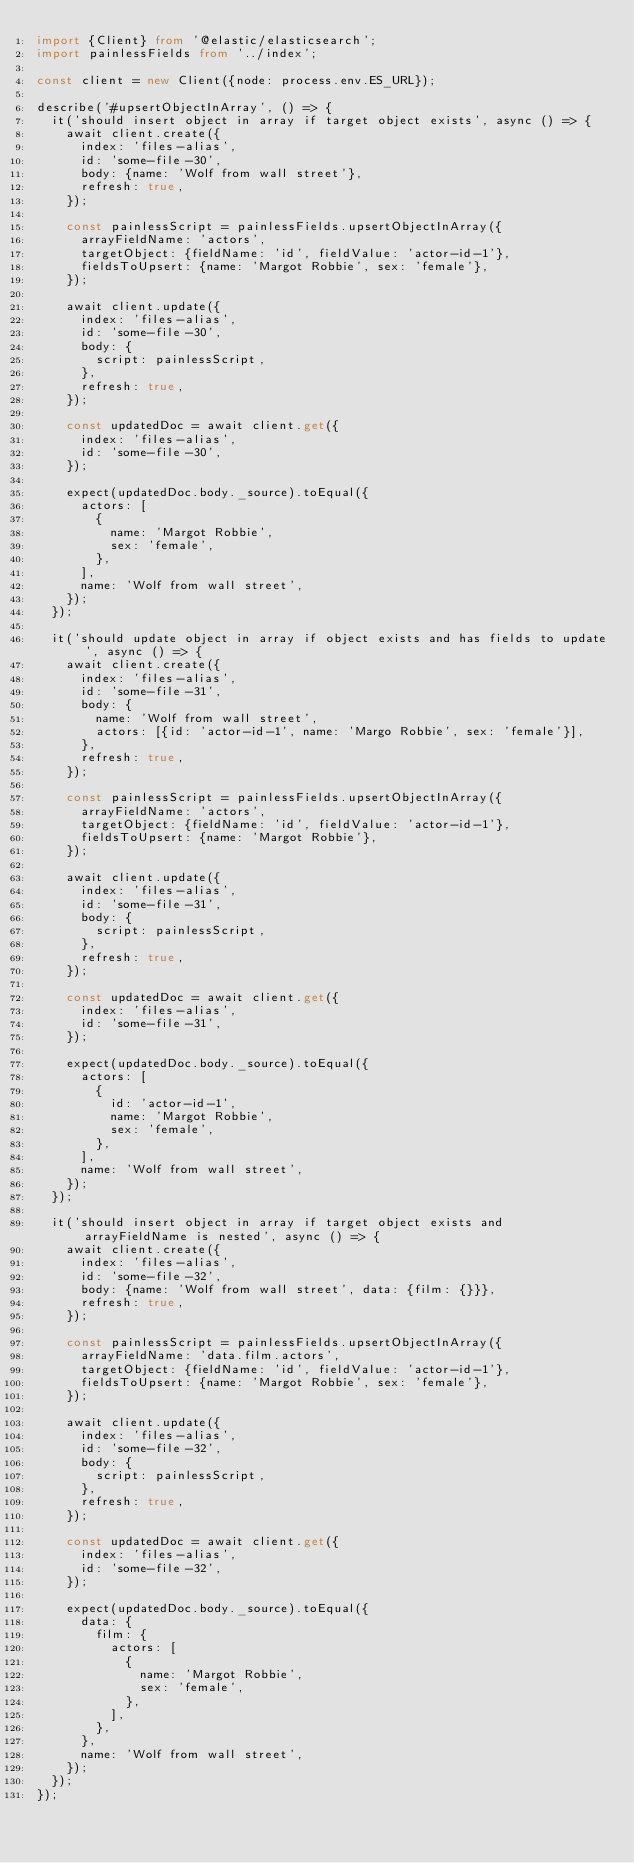<code> <loc_0><loc_0><loc_500><loc_500><_TypeScript_>import {Client} from '@elastic/elasticsearch';
import painlessFields from '../index';

const client = new Client({node: process.env.ES_URL});

describe('#upsertObjectInArray', () => {
  it('should insert object in array if target object exists', async () => {
    await client.create({
      index: 'files-alias',
      id: 'some-file-30',
      body: {name: 'Wolf from wall street'},
      refresh: true,
    });

    const painlessScript = painlessFields.upsertObjectInArray({
      arrayFieldName: 'actors',
      targetObject: {fieldName: 'id', fieldValue: 'actor-id-1'},
      fieldsToUpsert: {name: 'Margot Robbie', sex: 'female'},
    });

    await client.update({
      index: 'files-alias',
      id: 'some-file-30',
      body: {
        script: painlessScript,
      },
      refresh: true,
    });

    const updatedDoc = await client.get({
      index: 'files-alias',
      id: 'some-file-30',
    });

    expect(updatedDoc.body._source).toEqual({
      actors: [
        {
          name: 'Margot Robbie',
          sex: 'female',
        },
      ],
      name: 'Wolf from wall street',
    });
  });

  it('should update object in array if object exists and has fields to update', async () => {
    await client.create({
      index: 'files-alias',
      id: 'some-file-31',
      body: {
        name: 'Wolf from wall street',
        actors: [{id: 'actor-id-1', name: 'Margo Robbie', sex: 'female'}],
      },
      refresh: true,
    });

    const painlessScript = painlessFields.upsertObjectInArray({
      arrayFieldName: 'actors',
      targetObject: {fieldName: 'id', fieldValue: 'actor-id-1'},
      fieldsToUpsert: {name: 'Margot Robbie'},
    });

    await client.update({
      index: 'files-alias',
      id: 'some-file-31',
      body: {
        script: painlessScript,
      },
      refresh: true,
    });

    const updatedDoc = await client.get({
      index: 'files-alias',
      id: 'some-file-31',
    });

    expect(updatedDoc.body._source).toEqual({
      actors: [
        {
          id: 'actor-id-1',
          name: 'Margot Robbie',
          sex: 'female',
        },
      ],
      name: 'Wolf from wall street',
    });
  });

  it('should insert object in array if target object exists and arrayFieldName is nested', async () => {
    await client.create({
      index: 'files-alias',
      id: 'some-file-32',
      body: {name: 'Wolf from wall street', data: {film: {}}},
      refresh: true,
    });

    const painlessScript = painlessFields.upsertObjectInArray({
      arrayFieldName: 'data.film.actors',
      targetObject: {fieldName: 'id', fieldValue: 'actor-id-1'},
      fieldsToUpsert: {name: 'Margot Robbie', sex: 'female'},
    });

    await client.update({
      index: 'files-alias',
      id: 'some-file-32',
      body: {
        script: painlessScript,
      },
      refresh: true,
    });

    const updatedDoc = await client.get({
      index: 'files-alias',
      id: 'some-file-32',
    });

    expect(updatedDoc.body._source).toEqual({
      data: {
        film: {
          actors: [
            {
              name: 'Margot Robbie',
              sex: 'female',
            },
          ],
        },
      },
      name: 'Wolf from wall street',
    });
  });
});
</code> 